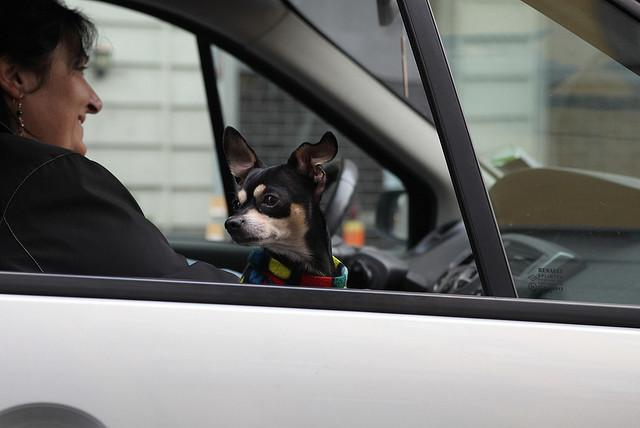What is this dog's owner doing?

Choices:
A) driving
B) shaving
C) drinking
D) sewing driving 